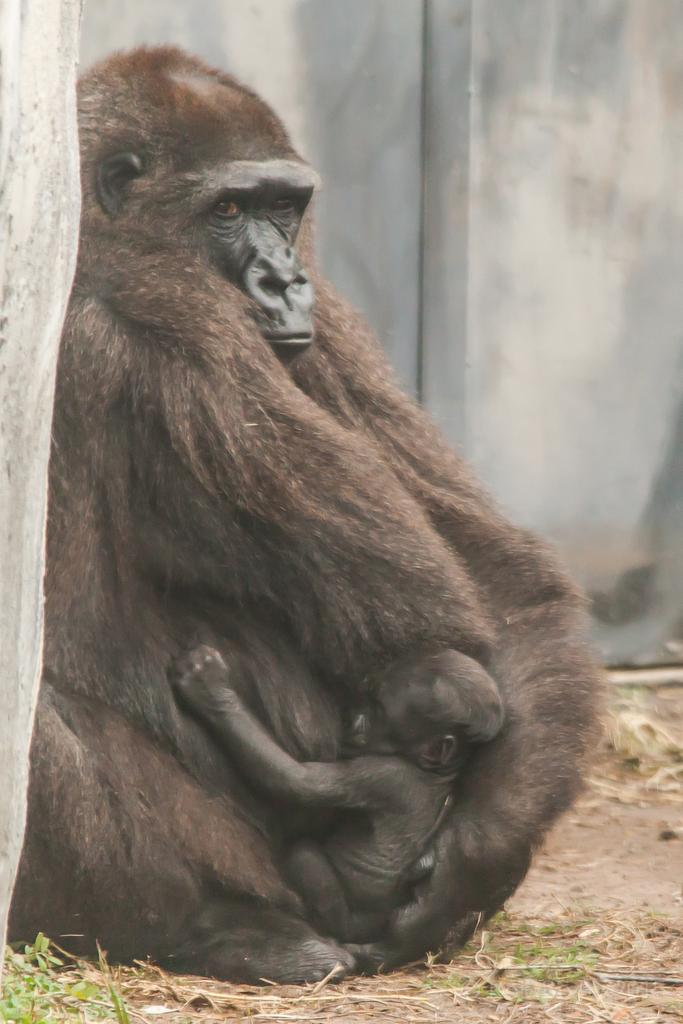What type of animal is in the image? There is a chimpanzee in the image. Who else is present in the image? There is an infant in the image. What can be seen in the background of the image? There is a wall in the background of the image. What is visible at the bottom of the image? The ground is visible at the bottom of the image. What type of holiday is being celebrated in the image? There is no indication of a holiday being celebrated in the image. 